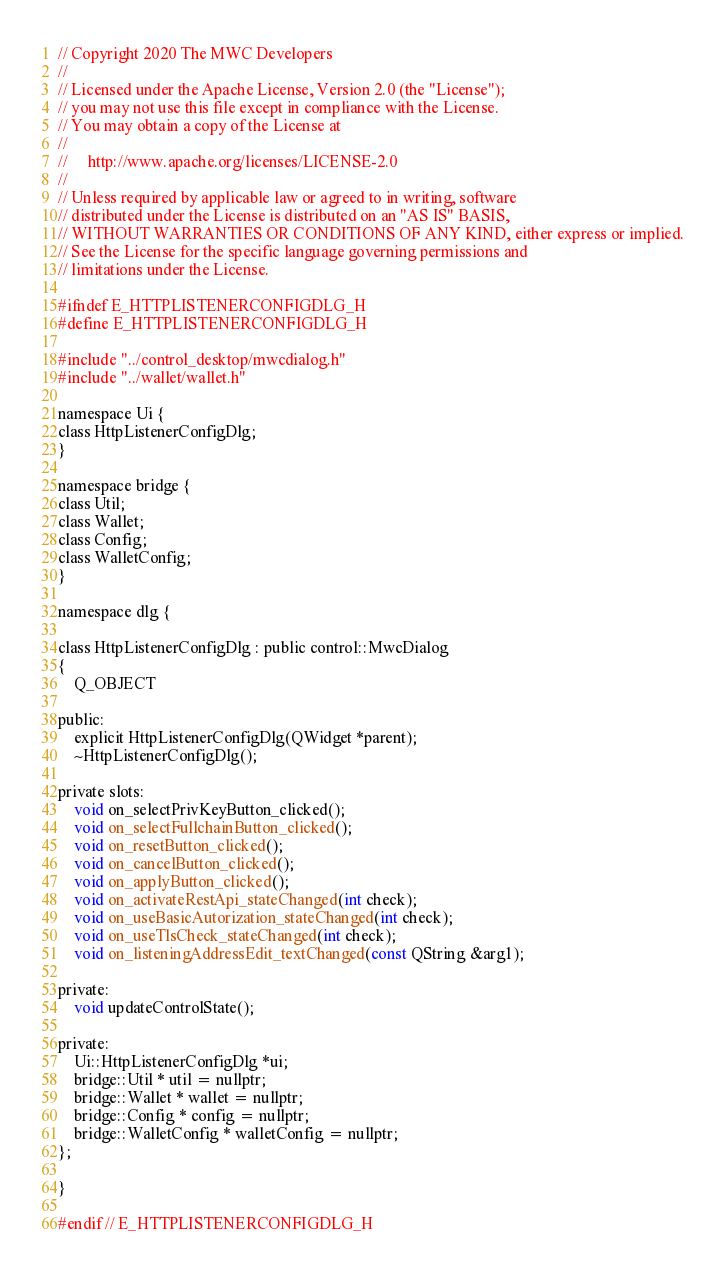<code> <loc_0><loc_0><loc_500><loc_500><_C_>// Copyright 2020 The MWC Developers
//
// Licensed under the Apache License, Version 2.0 (the "License");
// you may not use this file except in compliance with the License.
// You may obtain a copy of the License at
//
//     http://www.apache.org/licenses/LICENSE-2.0
//
// Unless required by applicable law or agreed to in writing, software
// distributed under the License is distributed on an "AS IS" BASIS,
// WITHOUT WARRANTIES OR CONDITIONS OF ANY KIND, either express or implied.
// See the License for the specific language governing permissions and
// limitations under the License.

#ifndef E_HTTPLISTENERCONFIGDLG_H
#define E_HTTPLISTENERCONFIGDLG_H

#include "../control_desktop/mwcdialog.h"
#include "../wallet/wallet.h"

namespace Ui {
class HttpListenerConfigDlg;
}

namespace bridge {
class Util;
class Wallet;
class Config;
class WalletConfig;
}

namespace dlg {

class HttpListenerConfigDlg : public control::MwcDialog
{
    Q_OBJECT

public:
    explicit HttpListenerConfigDlg(QWidget *parent);
    ~HttpListenerConfigDlg();

private slots:
    void on_selectPrivKeyButton_clicked();
    void on_selectFullchainButton_clicked();
    void on_resetButton_clicked();
    void on_cancelButton_clicked();
    void on_applyButton_clicked();
    void on_activateRestApi_stateChanged(int check);
    void on_useBasicAutorization_stateChanged(int check);
    void on_useTlsCheck_stateChanged(int check);
    void on_listeningAddressEdit_textChanged(const QString &arg1);

private:
    void updateControlState();

private:
    Ui::HttpListenerConfigDlg *ui;
    bridge::Util * util = nullptr;
    bridge::Wallet * wallet = nullptr;
    bridge::Config * config = nullptr;
    bridge::WalletConfig * walletConfig = nullptr;
};

}

#endif // E_HTTPLISTENERCONFIGDLG_H
</code> 